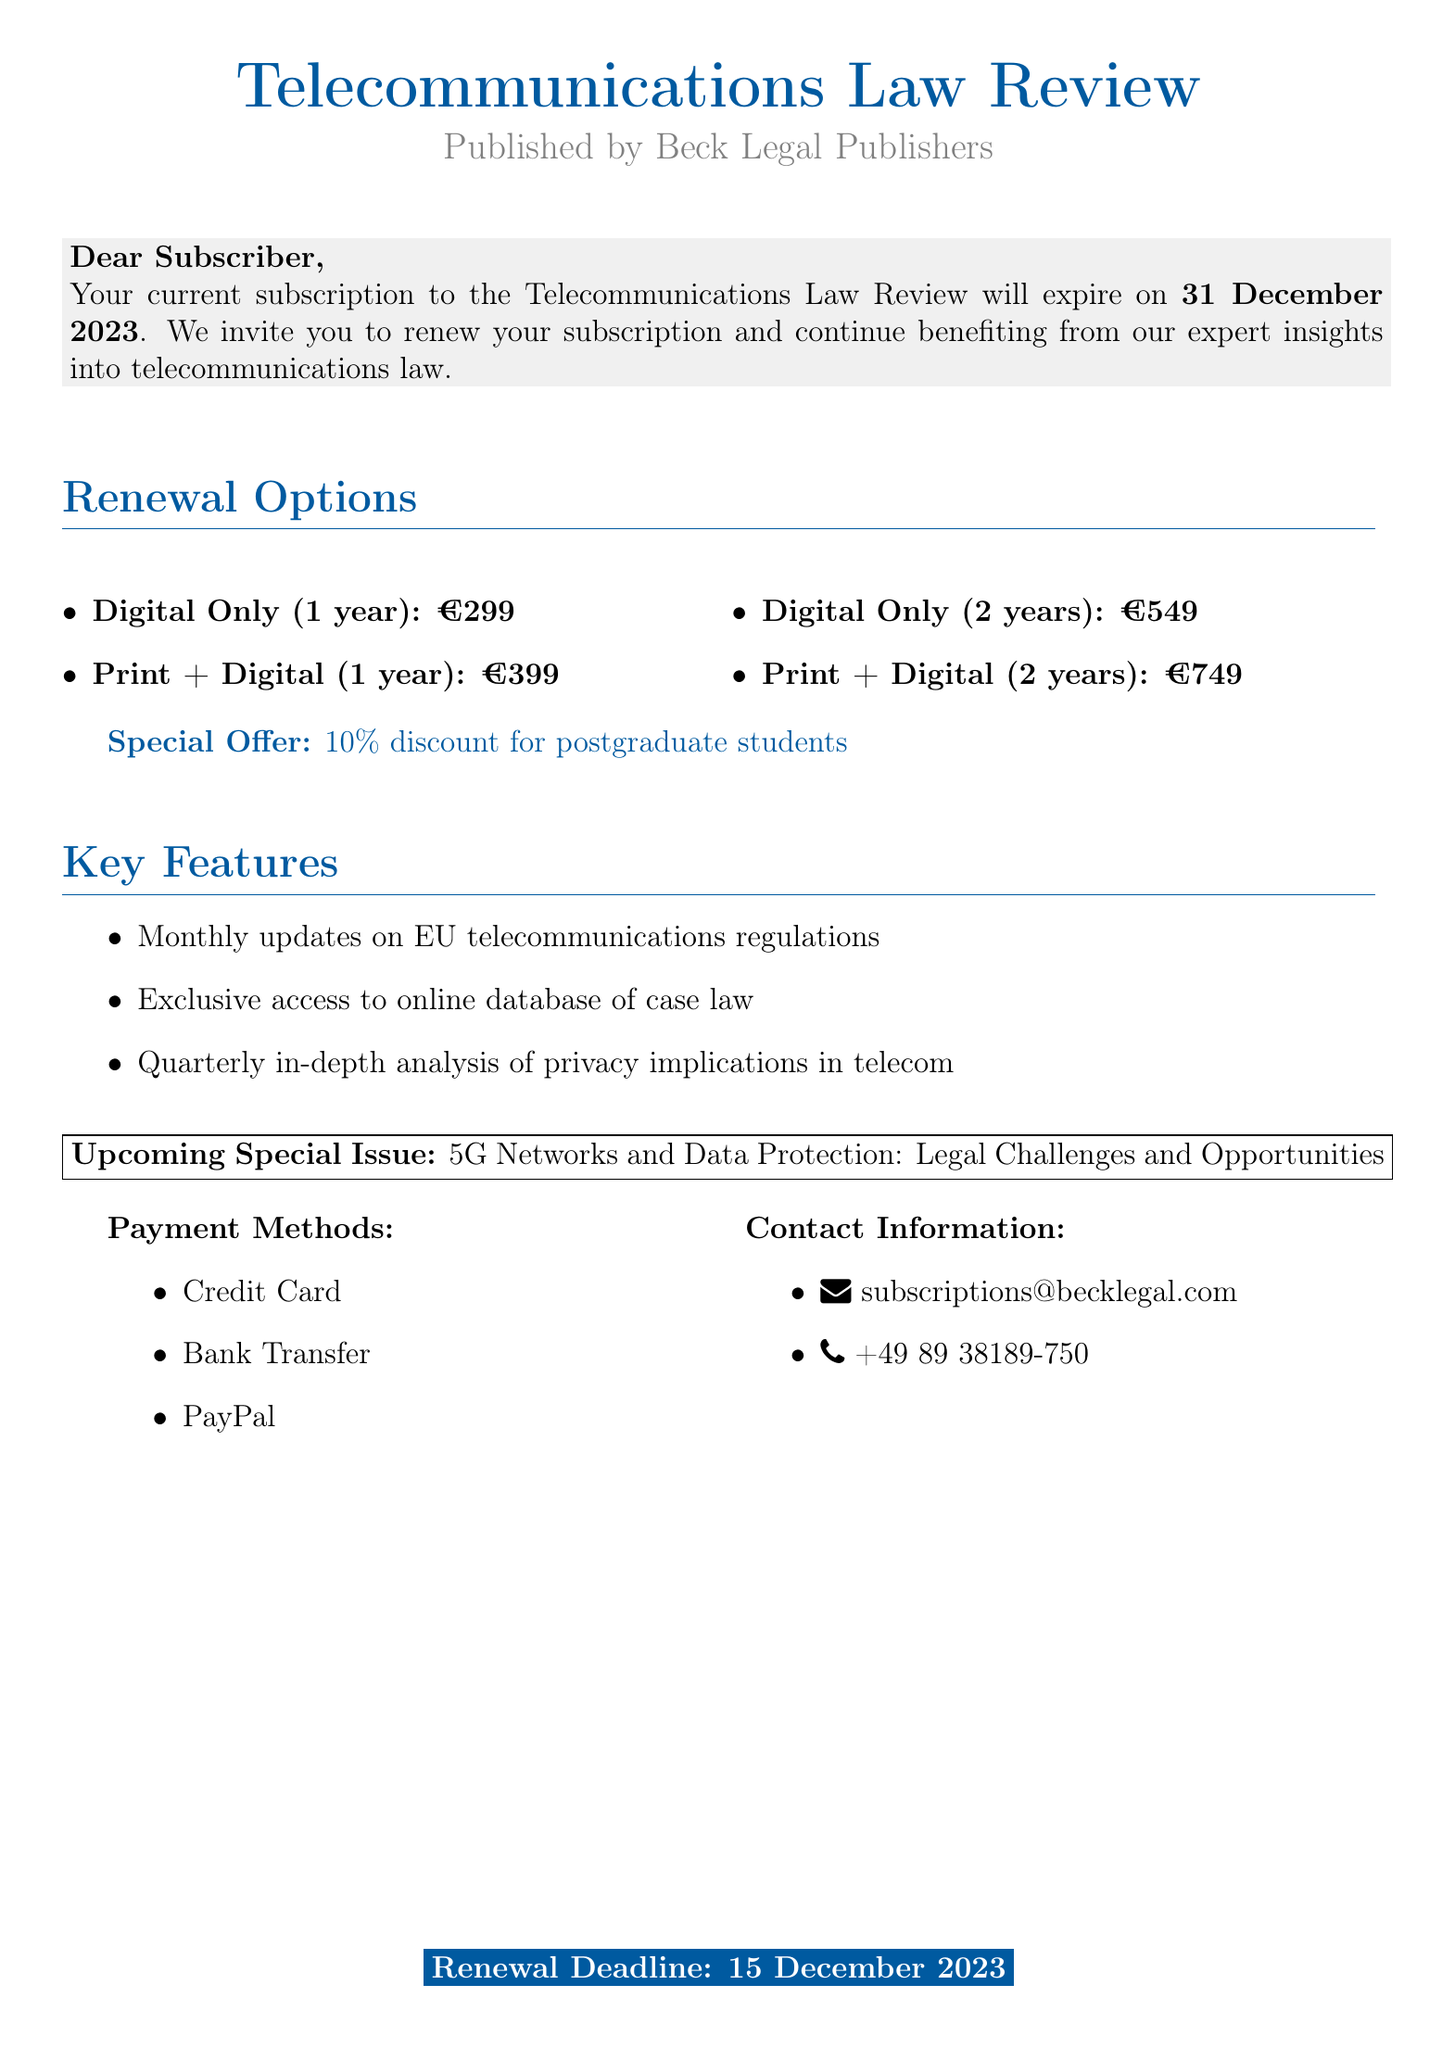What is the name of the journal? The name of the journal is mentioned at the top of the document.
Answer: Telecommunications Law Review Who publishes the journal? The publisher's name is specified in the document.
Answer: Beck Legal Publishers When does the current subscription expire? The expiry date of the current subscription is stated clearly in the document.
Answer: 31 December 2023 What is the price for a Digital Only subscription for 1 year? The price for that specific subscription type and duration is listed in the renewal options.
Answer: €299 What special offer is available for postgraduate students? The document specifies a particular discount that applies to postgraduate students.
Answer: 10% discount What is the renewal deadline? The document specifies a particular date as the renewal deadline.
Answer: 15 December 2023 What are the payment methods mentioned? The document lists the accepted payment methods for subscription.
Answer: Credit Card, Bank Transfer, PayPal What is included in the key features of the subscription? The document outlines certain highlights related to the subscription's benefits.
Answer: Monthly updates on EU telecommunications regulations What is the topic of the upcoming special issue? The upcoming special issue is mentioned as a point of interest in the document.
Answer: 5G Networks and Data Protection: Legal Challenges and Opportunities 